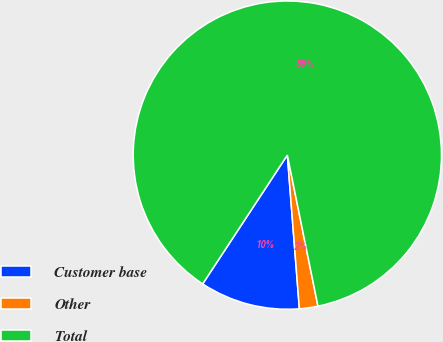Convert chart to OTSL. <chart><loc_0><loc_0><loc_500><loc_500><pie_chart><fcel>Customer base<fcel>Other<fcel>Total<nl><fcel>10.5%<fcel>1.94%<fcel>87.56%<nl></chart> 